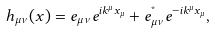Convert formula to latex. <formula><loc_0><loc_0><loc_500><loc_500>h _ { \mu \nu } ( x ) = e _ { \mu \nu } e ^ { i k ^ { \mu } x _ { \mu } } + e ^ { ^ { * } } _ { \mu \nu } e ^ { - i k ^ { \mu } x _ { \mu } } ,</formula> 